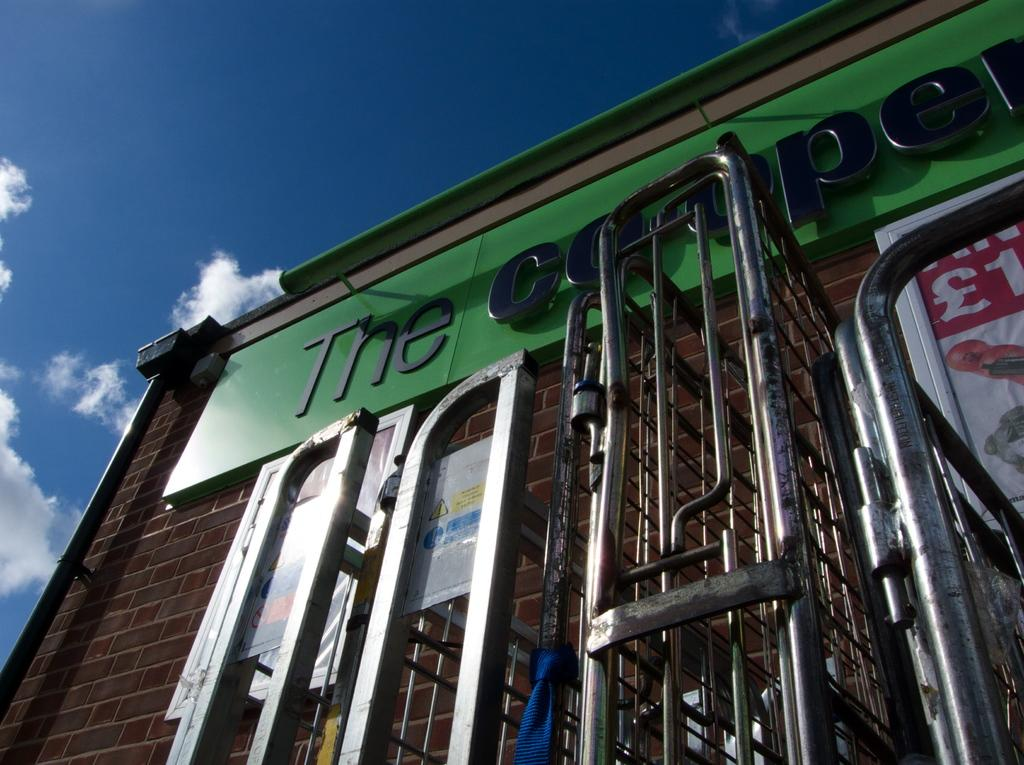Provide a one-sentence caption for the provided image. The Cooper sign on a building written in black. 